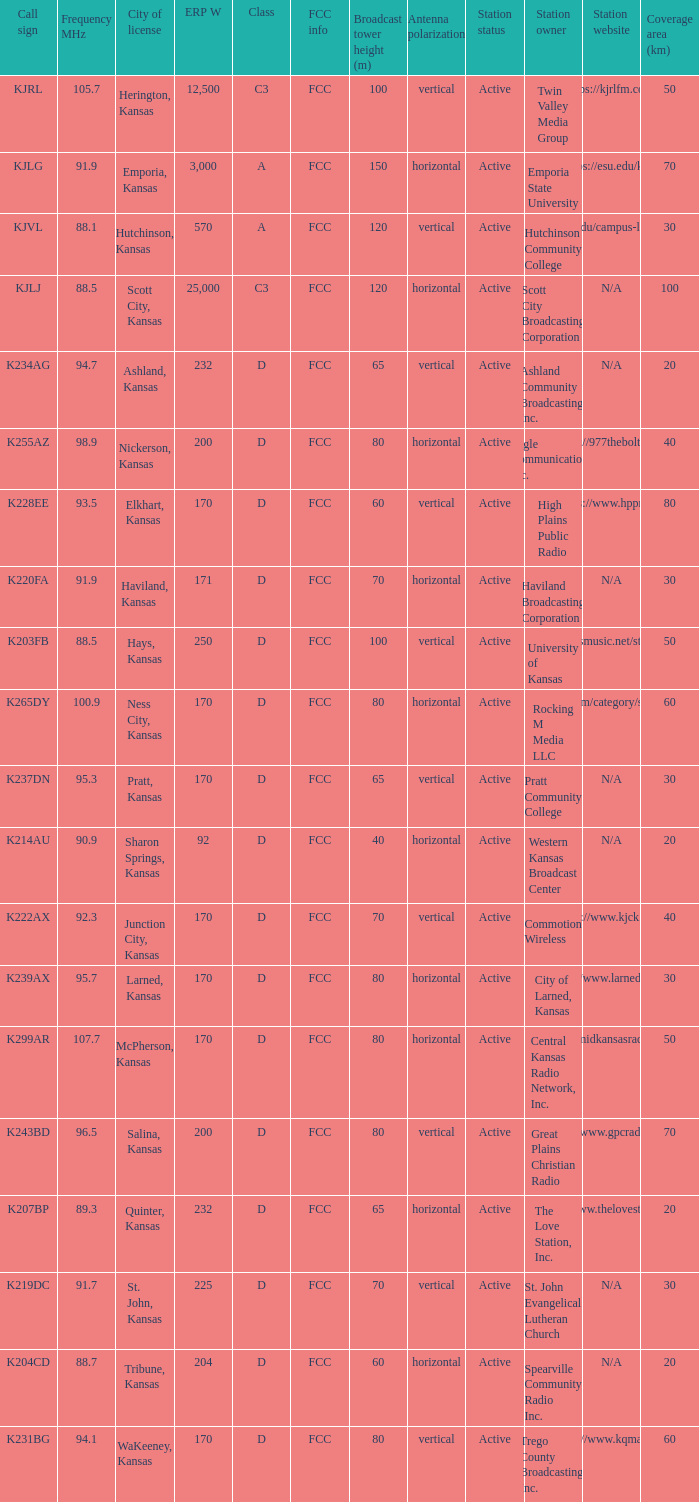Frequency MHz of 88.7 had what average erp w? 204.0. 